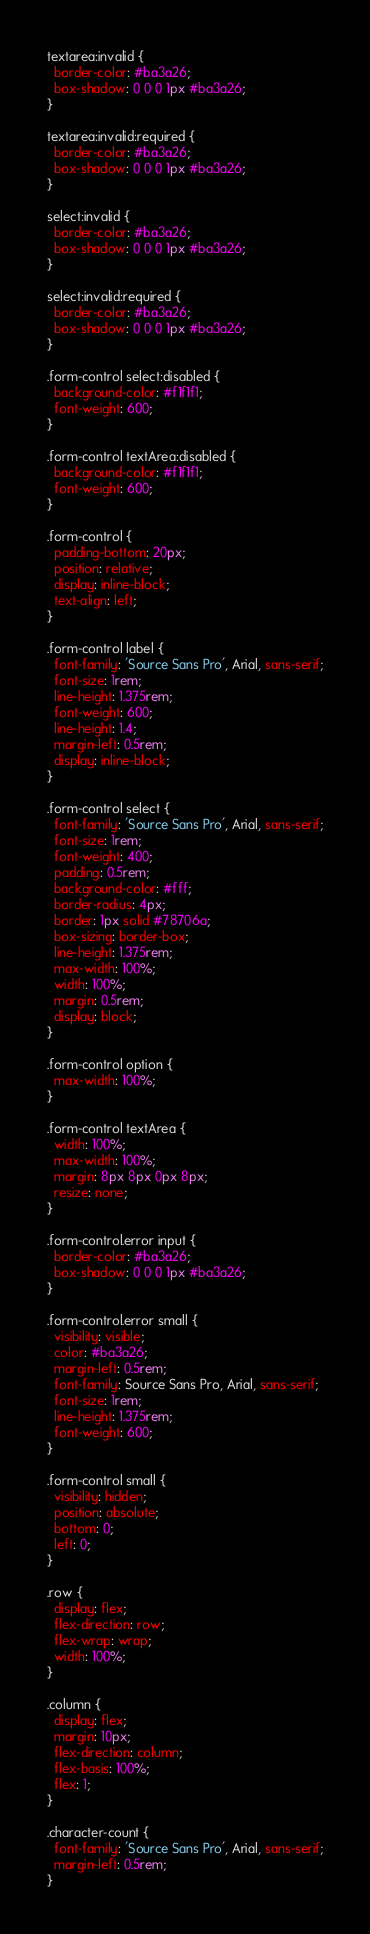Convert code to text. <code><loc_0><loc_0><loc_500><loc_500><_CSS_>textarea:invalid {
  border-color: #ba3a26;
  box-shadow: 0 0 0 1px #ba3a26;
}

textarea:invalid:required {
  border-color: #ba3a26;
  box-shadow: 0 0 0 1px #ba3a26;
}

select:invalid {
  border-color: #ba3a26;
  box-shadow: 0 0 0 1px #ba3a26;
}

select:invalid:required {
  border-color: #ba3a26;
  box-shadow: 0 0 0 1px #ba3a26;
}

.form-control select:disabled {
  background-color: #f1f1f1;
  font-weight: 600;
}

.form-control textArea:disabled {
  background-color: #f1f1f1;
  font-weight: 600;
}

.form-control {
  padding-bottom: 20px;
  position: relative;
  display: inline-block;
  text-align: left;
}

.form-control label {
  font-family: 'Source Sans Pro', Arial, sans-serif;
  font-size: 1rem;
  line-height: 1.375rem;
  font-weight: 600;
  line-height: 1.4;
  margin-left: 0.5rem;
  display: inline-block;
}

.form-control select {
  font-family: 'Source Sans Pro', Arial, sans-serif;
  font-size: 1rem;
  font-weight: 400;
  padding: 0.5rem;
  background-color: #fff;
  border-radius: 4px;
  border: 1px solid #78706a;
  box-sizing: border-box;
  line-height: 1.375rem;
  max-width: 100%;
  width: 100%;
  margin: 0.5rem;
  display: block;
}

.form-control option {
  max-width: 100%;
}

.form-control textArea {
  width: 100%;
  max-width: 100%;
  margin: 8px 8px 0px 8px;
  resize: none;
}

.form-control.error input {
  border-color: #ba3a26;
  box-shadow: 0 0 0 1px #ba3a26;
}

.form-control.error small {
  visibility: visible;
  color: #ba3a26;
  margin-left: 0.5rem;
  font-family: Source Sans Pro, Arial, sans-serif;
  font-size: 1rem;
  line-height: 1.375rem;
  font-weight: 600;
}

.form-control small {
  visibility: hidden;
  position: absolute;
  bottom: 0;
  left: 0;
}

.row {
  display: flex;
  flex-direction: row;
  flex-wrap: wrap;
  width: 100%;
}

.column {
  display: flex;
  margin: 10px;
  flex-direction: column;
  flex-basis: 100%;
  flex: 1;
}

.character-count {
  font-family: 'Source Sans Pro', Arial, sans-serif;
  margin-left: 0.5rem;
}
</code> 